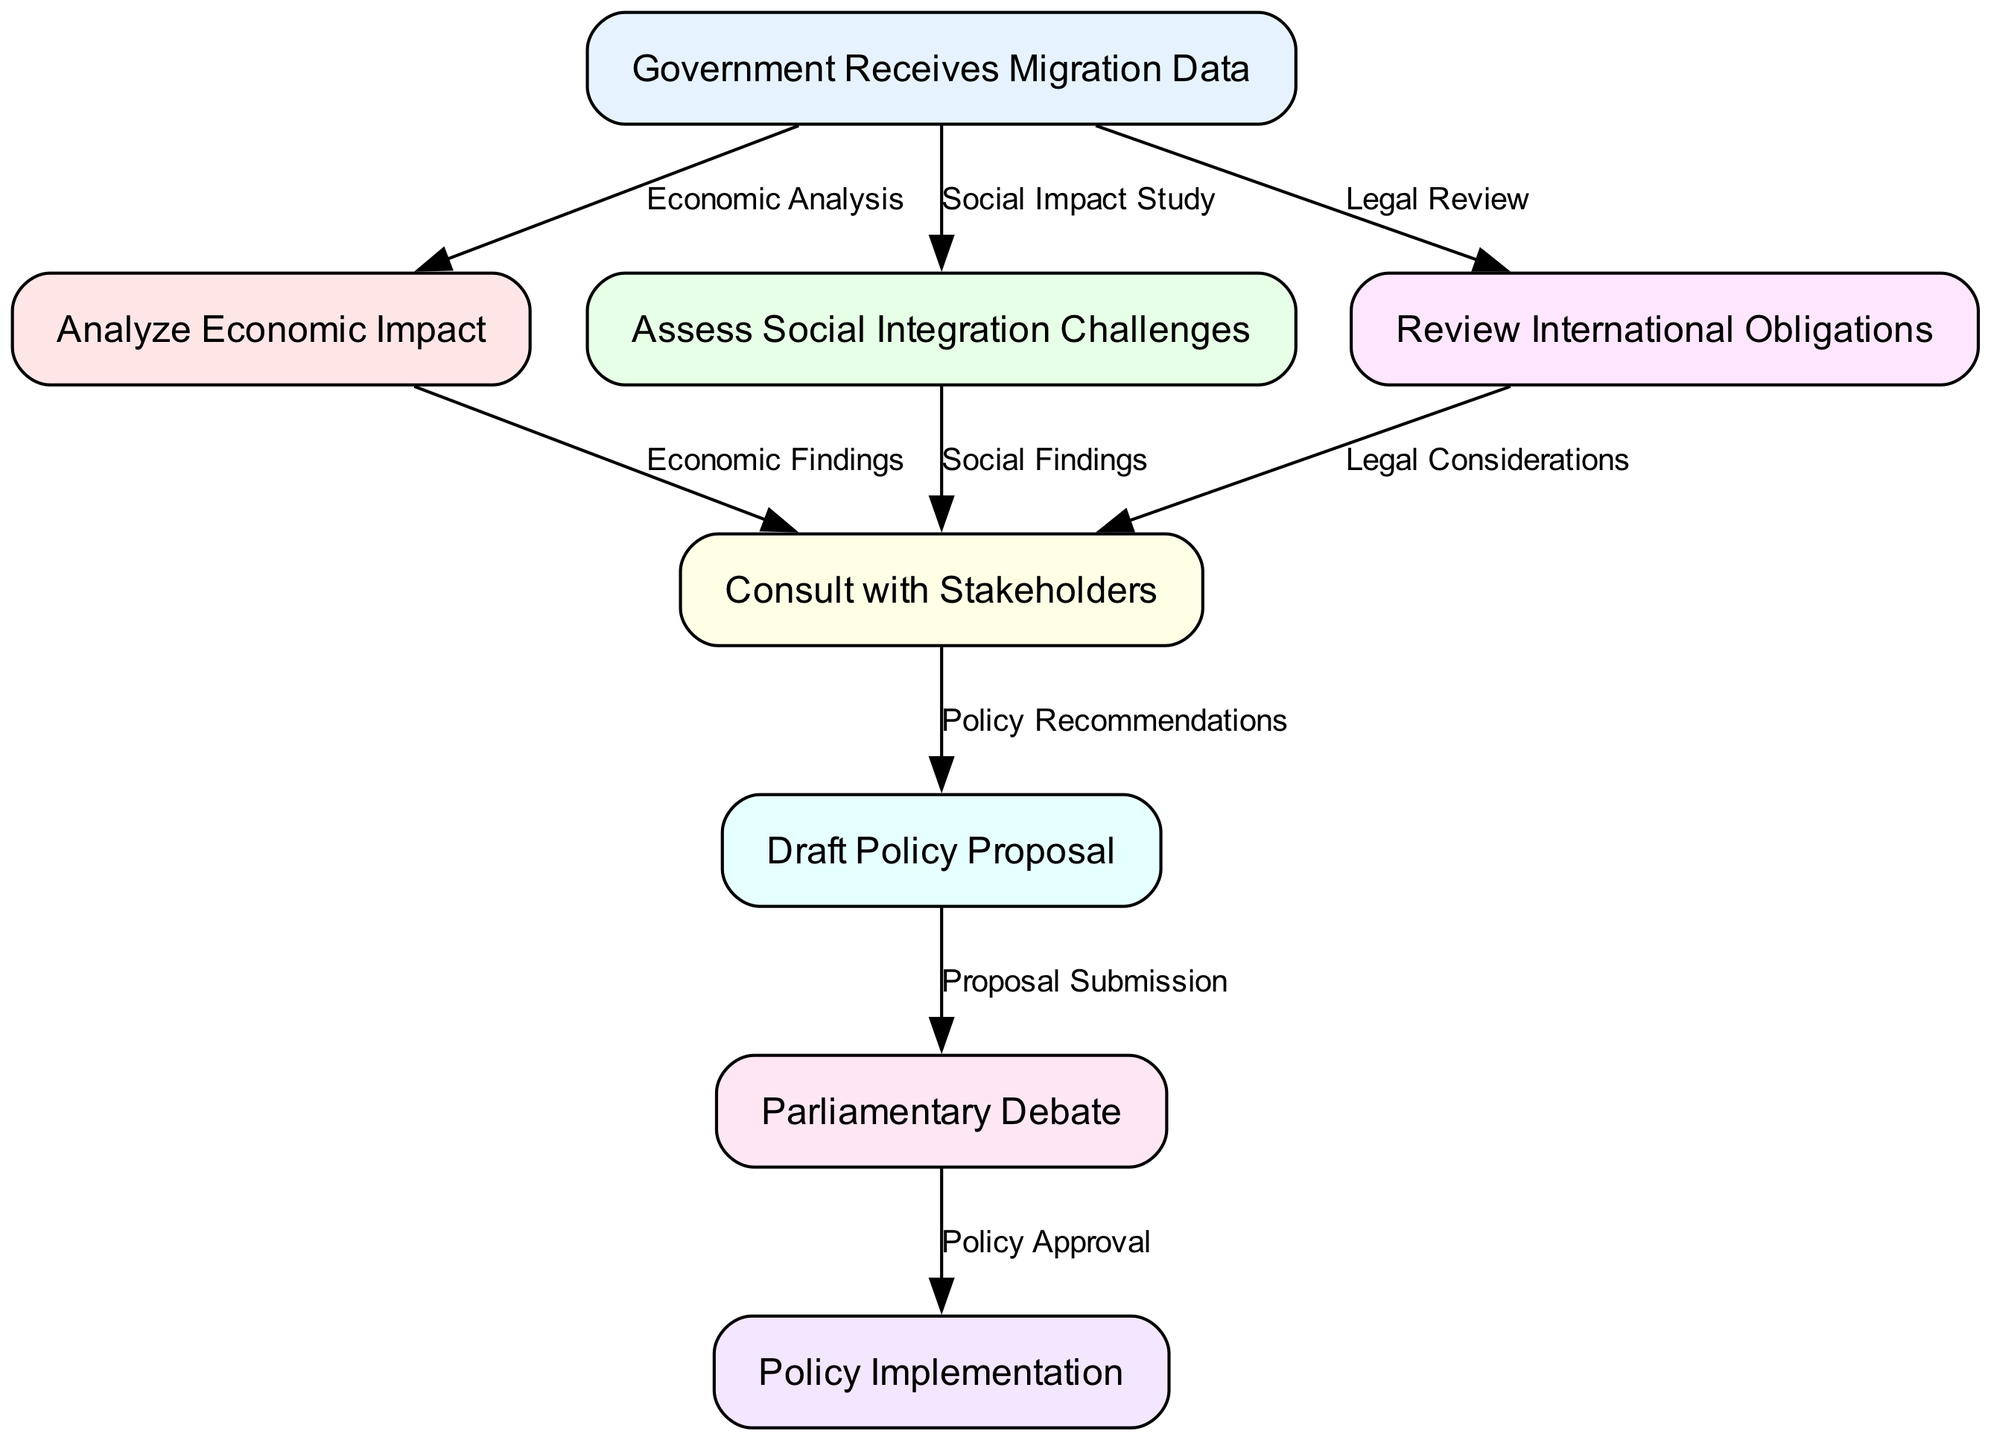What is the first step in the migration policy decision-making process? The first step is represented by the node labeled "Government Receives Migration Data." This indicates that the process begins with the collection of relevant migration data by the government.
Answer: Government Receives Migration Data How many nodes are present in the diagram? By counting all the unique elements labeled as nodes in the diagram, we find that there are a total of eight nodes. Each node represents a distinct step in the policy-making process.
Answer: 8 What is the last stage outlined in the pathway? The last stage in the pathway is labeled "Policy Implementation." This marks the completion of the decision-making process where the approved policy is put into action.
Answer: Policy Implementation Which step is related to legal considerations? The step related to legal considerations is called "Review International Obligations." This indicates an examination of international laws and commitments before moving forward with policy proposals.
Answer: Review International Obligations How many types of findings are consulted before drafting the policy proposal? There are three types of findings: Economic Findings, Social Findings, and Legal Considerations. These findings result from analyzing the economic impact, assessing social integration challenges, and reviewing international obligations, respectively.
Answer: 3 What follows after drafting the policy proposal? After drafting the policy proposal, the next step is "Parliamentary Debate." This is where lawmakers discuss and deliberate on the proposed policy before making a decision.
Answer: Parliamentary Debate How many edges are there in the diagram? To determine the number of edges, we count the connections between nodes in the diagram. There are a total of eight edges depicting the flow and relationships between different steps of the process.
Answer: 8 What connects "Assess Social Integration Challenges" to "Consult with Stakeholders"? The connection is made through "Social Findings," indicating that the assessment of social integration issues leads to consultations with stakeholders for further input.
Answer: Social Findings Which two nodes are connected by the edge labeled "Proposal Submission"? The edge labeled "Proposal Submission" connects the node "Draft Policy Proposal" to the node "Parliamentary Debate." This edge signifies that the drafted proposal is submitted for debate in parliament.
Answer: Draft Policy Proposal and Parliamentary Debate 